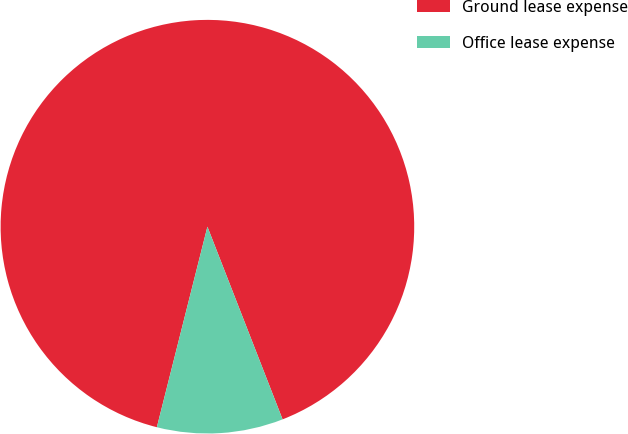Convert chart to OTSL. <chart><loc_0><loc_0><loc_500><loc_500><pie_chart><fcel>Ground lease expense<fcel>Office lease expense<nl><fcel>90.15%<fcel>9.85%<nl></chart> 